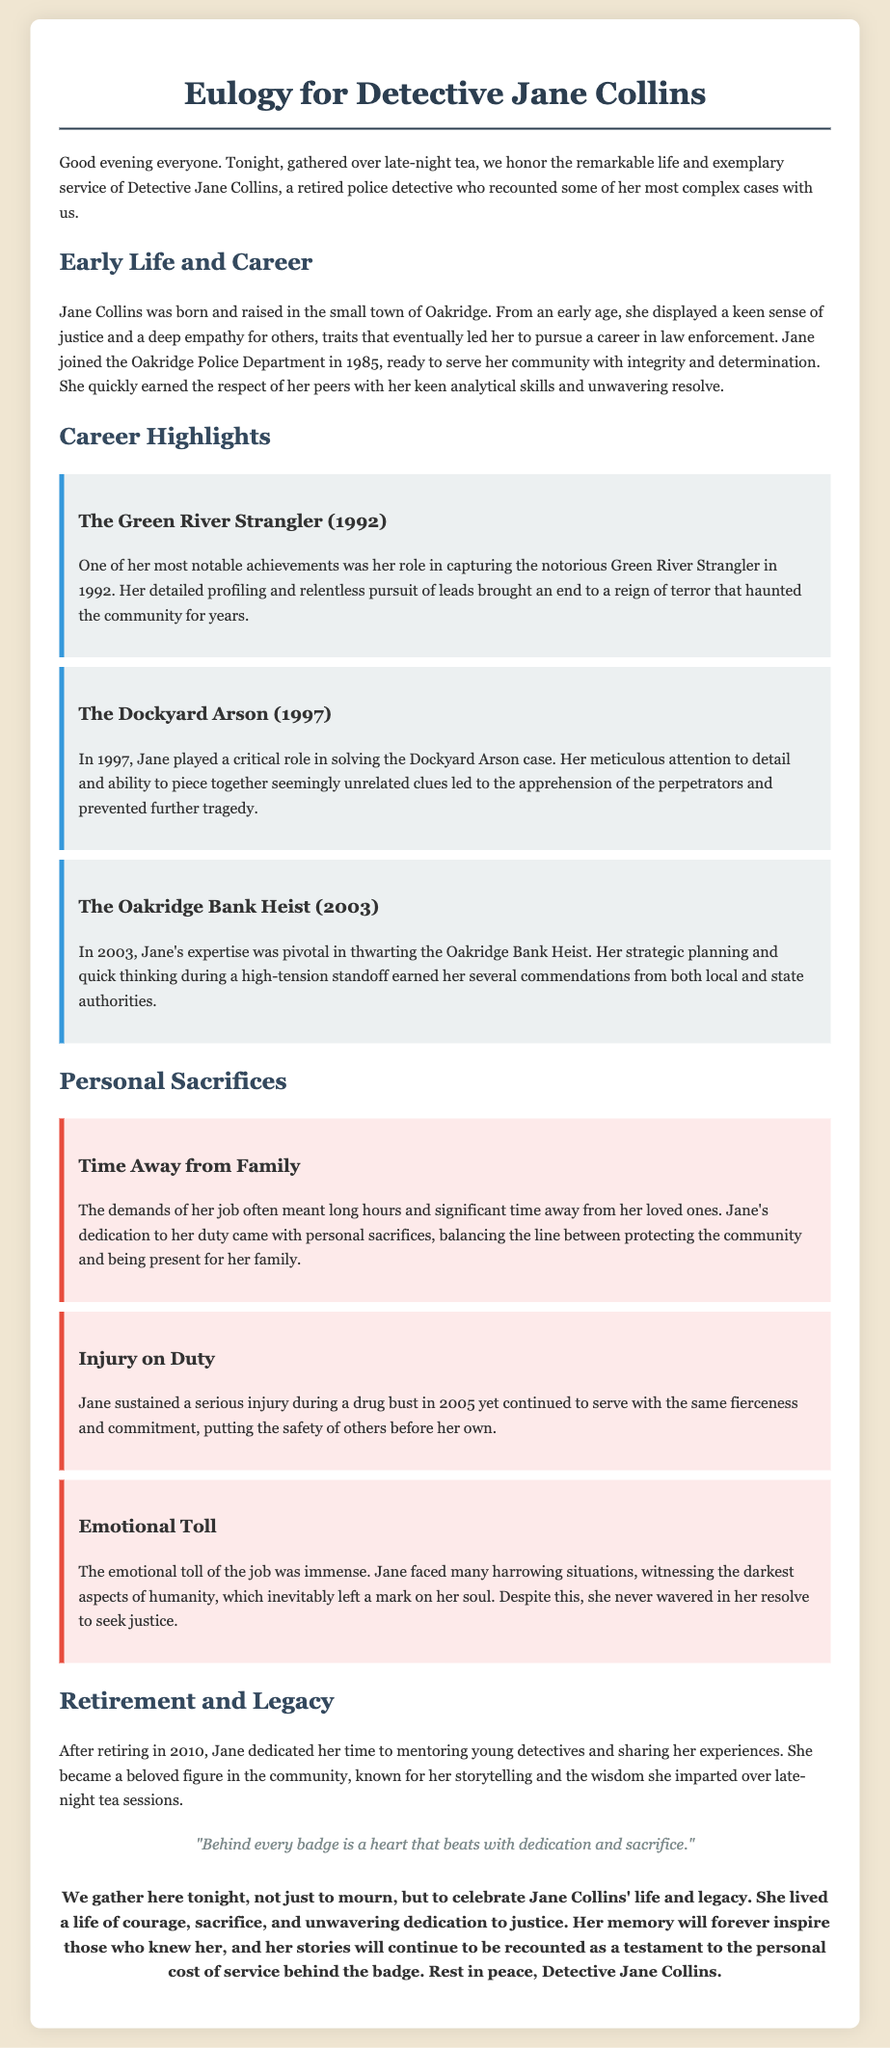What year did Jane Collins join the Oakridge Police Department? The document states that Jane Collins joined the Oakridge Police Department in 1985.
Answer: 1985 Who was involved in the Green River Strangler case? Jane Collins played a notable role in capturing the Green River Strangler, which is highlighted in the document.
Answer: Jane Collins What major event occurred in 2005 related to Jane? The document mentions that Jane sustained a serious injury during a drug bust in 2005.
Answer: Injury What was Jane's primary role after retirement? After retiring, Jane dedicated her time to mentoring young detectives, as per the eulogy.
Answer: Mentoring How did Jane’s career impact her family life? The eulogy discusses the personal sacrifices Jane made, including long hours away from her loved ones due to her job.
Answer: Long hours What was the emotional cost of Jane's career? The document indicates that Jane faced immense emotional toll due to harrowing situations she encountered.
Answer: Immense emotional toll What did Jane become known for after her retirement? She became a beloved figure known for her storytelling and wisdom shared during late-night tea.
Answer: Storytelling What is the significant quote in the document? The eulogy includes a quote regarding the dedication and sacrifice behind the badge, emphasizing the personal cost of service.
Answer: "Behind every badge is a heart that beats with dedication and sacrifice." 